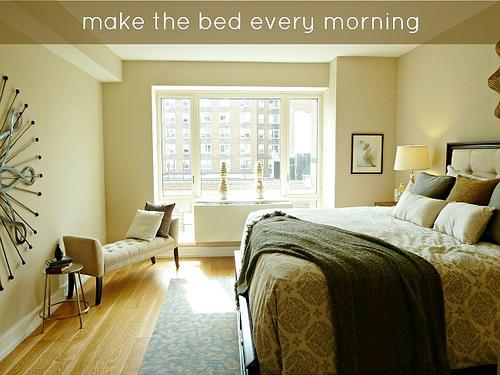What type of artwork can we observe on the walls of the bedroom? We can observe a large metal wall decor, framed wall art, and a picture hanging from the wall. Provide a concise description of the primary elements in the image. A luxurious hotel bedroom with a well-decorated bed, pillows, hardwood floors, colorful area rug, framed wall art, bench, and table with a lit bedside lamp. Point out the presence of any furniture near the hotel room walls. There is a table, stool, and a sitting bench positioned near the walls of the hotel room. Is there any source of light in the room? If yes, describe it. Yes, there is a bedside lamp on a table, and it is turned on with a white lamp shade. What can we infer about the overall feel and quality of the bedroom? The bedroom appears to be luxurious, well-decorated, and part of a five-star hotel. What is the appearance and location of the sitting bench in this bedroom scene? The sitting bench near the window is white and has two throw pillows placed on top of it. Briefly explain the appearance of the large bedroom window in the image. The large bedroom window has two decorative small lamps beside it and seems to provide a view of the hotel surroundings. How many throw pillows can be seen on the bed? Two rectangular throw pillows. Describe the floor and any possible covering on it. The floor is made of light hardwood, and there is an area rug covering a portion of it. What colors are the two throw pillows on the bed? One throw pillow is red, and the other one is green. Did you see the elegant chandelier hanging from the ceiling in the center of the room? Its sparkling crystals create a stunning visual effect. Have you admired the potted palm tree in the corner of the room, enhancing the room's tropical vibes? This plant adds a natural touch to the hotel room. Can you spot the round-shaped vase on the glass stand beside the bed? The vase features intricate designs and beautiful colors. Can you identify the exquisite painting of a tranquil beach scene on the wall by the bed? It brings a sense of calm and serenity to the hotel room. Are you noticing the vintage wooden wardrobe near the large bedroom window? Its unique design and rich wood finish add to the room's luxurious atmosphere. Take a closer look at the open closet on the right side of the room, full of neatly organized clothes and accessories. You may find it useful to get some organization ideas from it. 